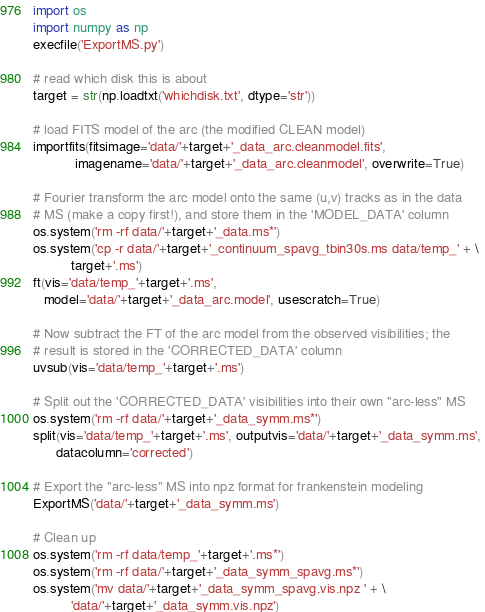<code> <loc_0><loc_0><loc_500><loc_500><_Python_>import os
import numpy as np
execfile('ExportMS.py')

# read which disk this is about
target = str(np.loadtxt('whichdisk.txt', dtype='str'))

# load FITS model of the arc (the modified CLEAN model)
importfits(fitsimage='data/'+target+'_data_arc.cleanmodel.fits',
           imagename='data/'+target+'_data_arc.cleanmodel', overwrite=True)

# Fourier transform the arc model onto the same (u,v) tracks as in the data
# MS (make a copy first!), and store them in the 'MODEL_DATA' column
os.system('rm -rf data/'+target+'_data.ms*')
os.system('cp -r data/'+target+'_continuum_spavg_tbin30s.ms data/temp_' + \
          target+'.ms')
ft(vis='data/temp_'+target+'.ms', 
   model='data/'+target+'_data_arc.model', usescratch=True)

# Now subtract the FT of the arc model from the observed visibilities; the 
# result is stored in the 'CORRECTED_DATA' column
uvsub(vis='data/temp_'+target+'.ms')

# Split out the 'CORRECTED_DATA' visibilities into their own "arc-less" MS
os.system('rm -rf data/'+target+'_data_symm.ms*')
split(vis='data/temp_'+target+'.ms', outputvis='data/'+target+'_data_symm.ms', 
      datacolumn='corrected')

# Export the "arc-less" MS into npz format for frankenstein modeling
ExportMS('data/'+target+'_data_symm.ms')

# Clean up
os.system('rm -rf data/temp_'+target+'.ms*')
os.system('rm -rf data/'+target+'_data_symm_spavg.ms*')
os.system('mv data/'+target+'_data_symm_spavg.vis.npz ' + \
          'data/'+target+'_data_symm.vis.npz')
</code> 